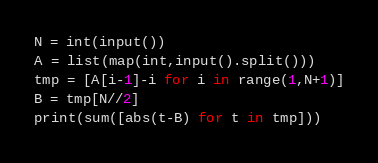Convert code to text. <code><loc_0><loc_0><loc_500><loc_500><_Python_>N = int(input())
A = list(map(int,input().split()))
tmp = [A[i-1]-i for i in range(1,N+1)]
B = tmp[N//2]
print(sum([abs(t-B) for t in tmp]))</code> 